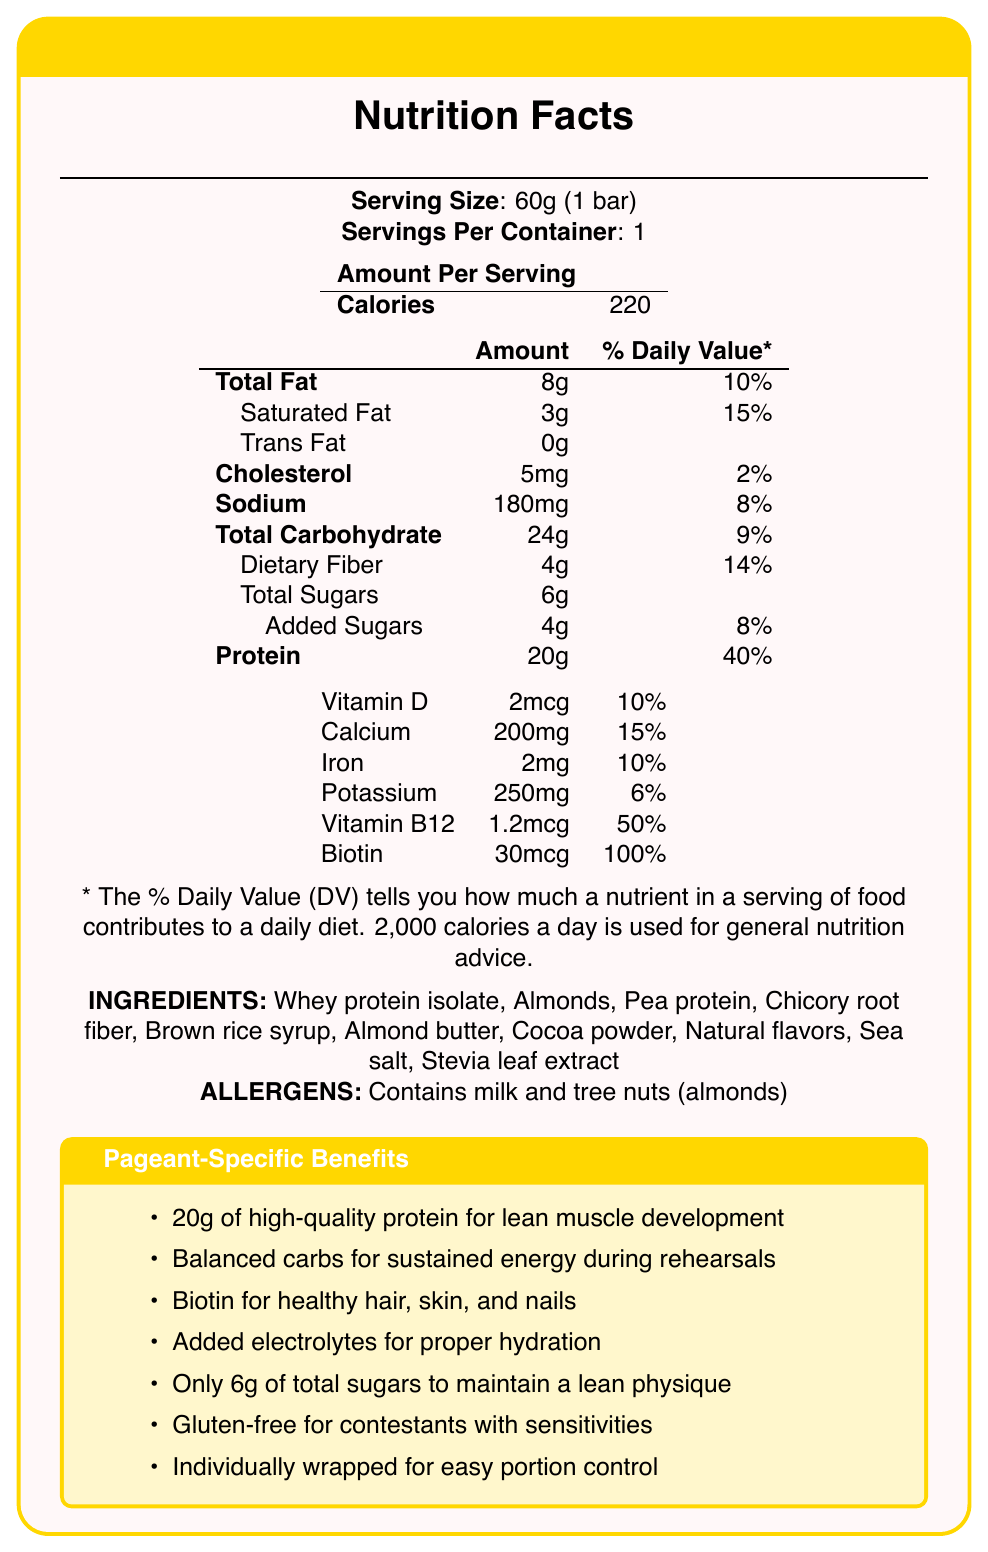what is the serving size for PageantPro High-Protein Snack Bar? The serving size is listed at the top of the nutrition facts section as 60g (1 bar).
Answer: 60g (1 bar) How many calories are there in one serving? The calorie count per serving is prominently displayed as 220 calories.
Answer: 220 What is the percentage of Daily Value for protein in this snack bar? The % Daily Value for protein is listed as 40%.
Answer: 40% Which ingredient is used as a sweetener in this snack bar? Stevia leaf extract is listed among the ingredients.
Answer: Stevia leaf extract What allergens are present in this product? The allergens section explicitly states that the product contains milk and tree nuts (almonds).
Answer: Contains milk and tree nuts (almonds) What is the main benefit of biotin mentioned in this document? The Pageant-Specific Benefits section mentions that biotin supports healthy hair, skin, and nails.
Answer: For healthy hair, skin, and nails How much sodium does one serving contain? The sodium content per serving is listed as 180mg.
Answer: 180mg What is the amount of dietary fiber in one serving? The dietary fiber amount is listed as 4g per serving.
Answer: 4g How much added sugars are in the PageantPro High-Protein Snack Bar? The label shows that the bar contains 4g of added sugars.
Answer: 4g Which vitamin has the highest percentage of Daily Value in this snack bar? A. Vitamin D B. Calcium C. Vitamin B12 D. Biotin Biotin has the highest percentage of Daily Value at 100%, compared to Vitamin D (10%), Calcium (15%), and Vitamin B12 (50%).
Answer: D. Biotin How many grams of total fat are in one serving? A. 6g B. 8g C. 10g D. 12g The document states that the total fat content is 8g per serving.
Answer: B. 8g Is this snack bar gluten-free? The Pageant-Specific Benefits section confirms that the snack bar is suitable for contestants with gluten sensitivities.
Answer: Yes Does this product contain any artificial flavors? The ingredient list includes "Natural flavors," indicating that there are no artificial flavors.
Answer: No Summarize the main nutritional benefits of the PageantPro High-Protein Snack Bar. The document emphasizes the high protein content for muscle development, balanced carbohydrates for sustained energy, and the inclusion of biotin for beauty support. Other benefits include added electrolytes for hydration, low sugar content, and being gluten-free.
Answer: This high-protein snack bar is designed for pageant fitness routines, offering 20g of protein to support muscle building, balanced carbs for energy, and additional vitamins and minerals for overall health. It is gluten-free, low in sugar, and individually wrapped for convenience. What is the price of the PageantPro High-Protein Snack Bar? The document does not provide any information regarding the price of the snack bar.
Answer: Cannot be determined What percentage of the Daily Value does iron contribute in this product? The nutrition facts table lists iron as contributing 10% to the Daily Value.
Answer: 10% 